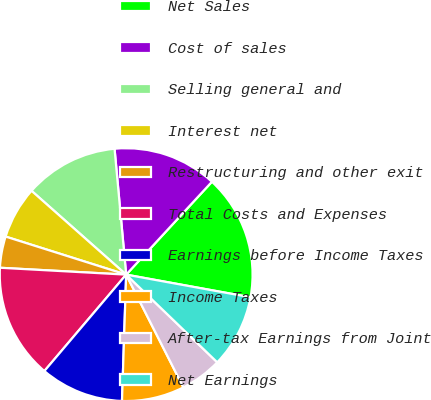<chart> <loc_0><loc_0><loc_500><loc_500><pie_chart><fcel>Net Sales<fcel>Cost of sales<fcel>Selling general and<fcel>Interest net<fcel>Restructuring and other exit<fcel>Total Costs and Expenses<fcel>Earnings before Income Taxes<fcel>Income Taxes<fcel>After-tax Earnings from Joint<fcel>Net Earnings<nl><fcel>16.0%<fcel>13.33%<fcel>12.0%<fcel>6.67%<fcel>4.0%<fcel>14.67%<fcel>10.67%<fcel>8.0%<fcel>5.33%<fcel>9.33%<nl></chart> 